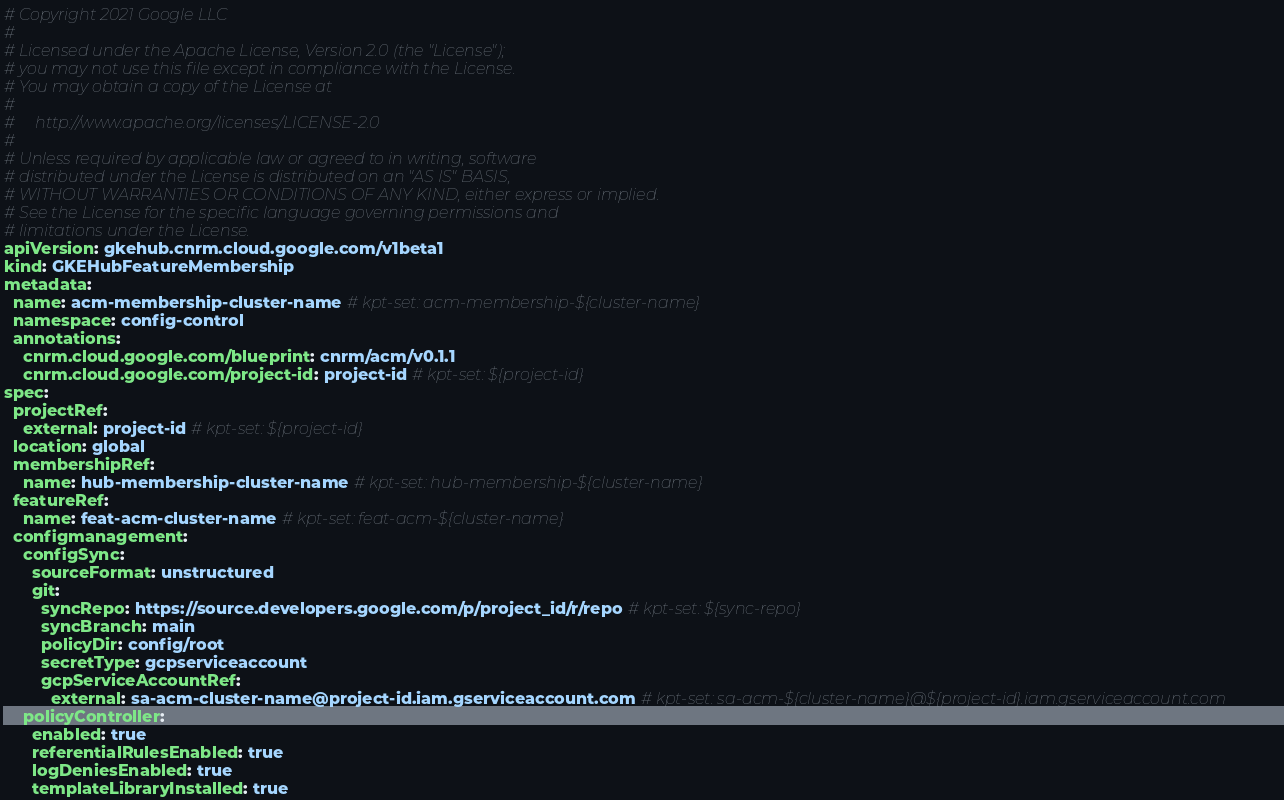Convert code to text. <code><loc_0><loc_0><loc_500><loc_500><_YAML_># Copyright 2021 Google LLC
#
# Licensed under the Apache License, Version 2.0 (the "License");
# you may not use this file except in compliance with the License.
# You may obtain a copy of the License at
#
#     http://www.apache.org/licenses/LICENSE-2.0
#
# Unless required by applicable law or agreed to in writing, software
# distributed under the License is distributed on an "AS IS" BASIS,
# WITHOUT WARRANTIES OR CONDITIONS OF ANY KIND, either express or implied.
# See the License for the specific language governing permissions and
# limitations under the License.
apiVersion: gkehub.cnrm.cloud.google.com/v1beta1
kind: GKEHubFeatureMembership
metadata:
  name: acm-membership-cluster-name # kpt-set: acm-membership-${cluster-name}
  namespace: config-control
  annotations:
    cnrm.cloud.google.com/blueprint: cnrm/acm/v0.1.1
    cnrm.cloud.google.com/project-id: project-id # kpt-set: ${project-id}
spec:
  projectRef:
    external: project-id # kpt-set: ${project-id}
  location: global
  membershipRef:
    name: hub-membership-cluster-name # kpt-set: hub-membership-${cluster-name}
  featureRef:
    name: feat-acm-cluster-name # kpt-set: feat-acm-${cluster-name}
  configmanagement:
    configSync:
      sourceFormat: unstructured
      git:
        syncRepo: https://source.developers.google.com/p/project_id/r/repo # kpt-set: ${sync-repo}
        syncBranch: main
        policyDir: config/root
        secretType: gcpserviceaccount
        gcpServiceAccountRef:
          external: sa-acm-cluster-name@project-id.iam.gserviceaccount.com # kpt-set: sa-acm-${cluster-name}@${project-id}.iam.gserviceaccount.com
    policyController:
      enabled: true
      referentialRulesEnabled: true
      logDeniesEnabled: true
      templateLibraryInstalled: true
</code> 